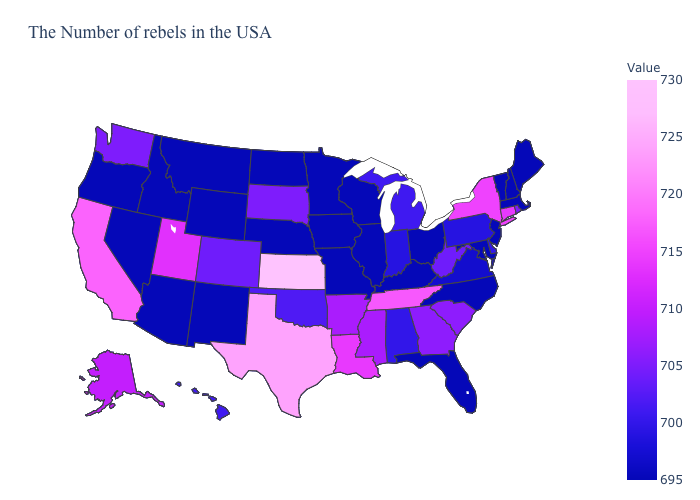Which states have the highest value in the USA?
Keep it brief. Kansas. Does Indiana have a lower value than Texas?
Keep it brief. Yes. Does Connecticut have a lower value than New Jersey?
Quick response, please. No. Among the states that border West Virginia , which have the lowest value?
Give a very brief answer. Maryland, Ohio, Kentucky. Which states have the lowest value in the MidWest?
Concise answer only. Ohio, Wisconsin, Illinois, Missouri, Minnesota, Iowa, Nebraska, North Dakota. 